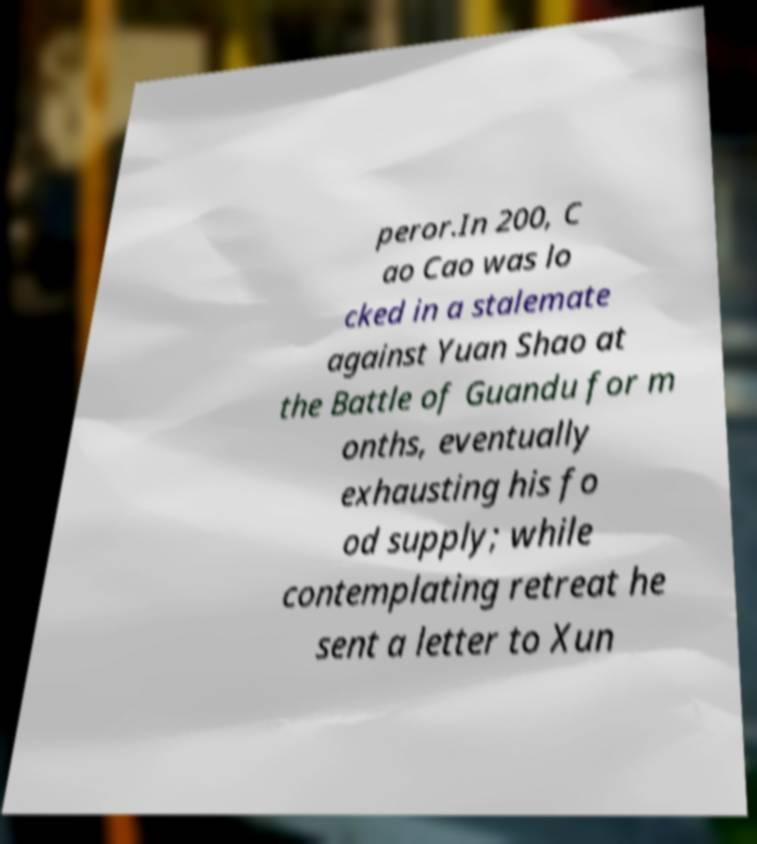Can you read and provide the text displayed in the image?This photo seems to have some interesting text. Can you extract and type it out for me? peror.In 200, C ao Cao was lo cked in a stalemate against Yuan Shao at the Battle of Guandu for m onths, eventually exhausting his fo od supply; while contemplating retreat he sent a letter to Xun 